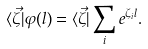<formula> <loc_0><loc_0><loc_500><loc_500>\langle \vec { \zeta } | \varphi ( l ) = \langle \vec { \zeta } | \sum _ { i } e ^ { \zeta _ { i } l } .</formula> 